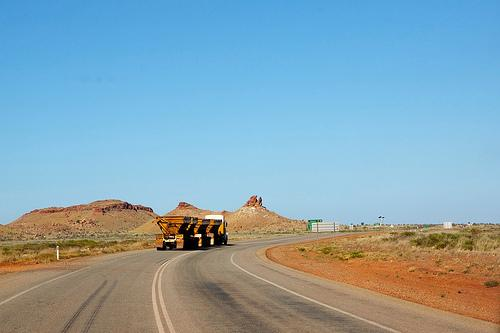Elaborate on the road markings visible in the scene. There are black tire marks, white double center lines, and white lines on the left and right sides of the curved road. Mention the primary object on the road and its significant features. A white truck carrying three trailers with a yellow and black design is traveling on the curved road. Comment on the condition of the sky and any visible weather phenomena. The sky in the image is cloudless, showcasing a bright blue color with no visible weather occurrences. Describe the characteristics of the road surface and how it appears. The road surface has skid marks, tire marks, and brownish patches, making it look uneven and textured. Write about the truck's cargo and its color scheme. The truck carries a huge load in its three trailers, with a yellow and black design, and white and yellow sides. Identify the overall environment and dominant colors in the image. The image features a cloudless bright blue sky, brownish ground by the road, and green shrubs on the dirt roadside. Mention any small details or objects near the road in the image. There is a white pole, a white marker in the ground, and pieces of stone by the roadside in the scene. Explain the geological features visible in the background. A red rock sticks into the air, a crag sticks out, and there are hills in front of the truck and mounds of dirt in the distance. Point out the signage elements present in the image. There is a white mile marker on the roadside, a green sign, the back of a white sign, and highway signs in the distance on the right. Describe the vegetation near the road and in the background. There are green shrubs on the dirt roadside, palm trees in the distance, and a patch of green grass on the right side of the road. 